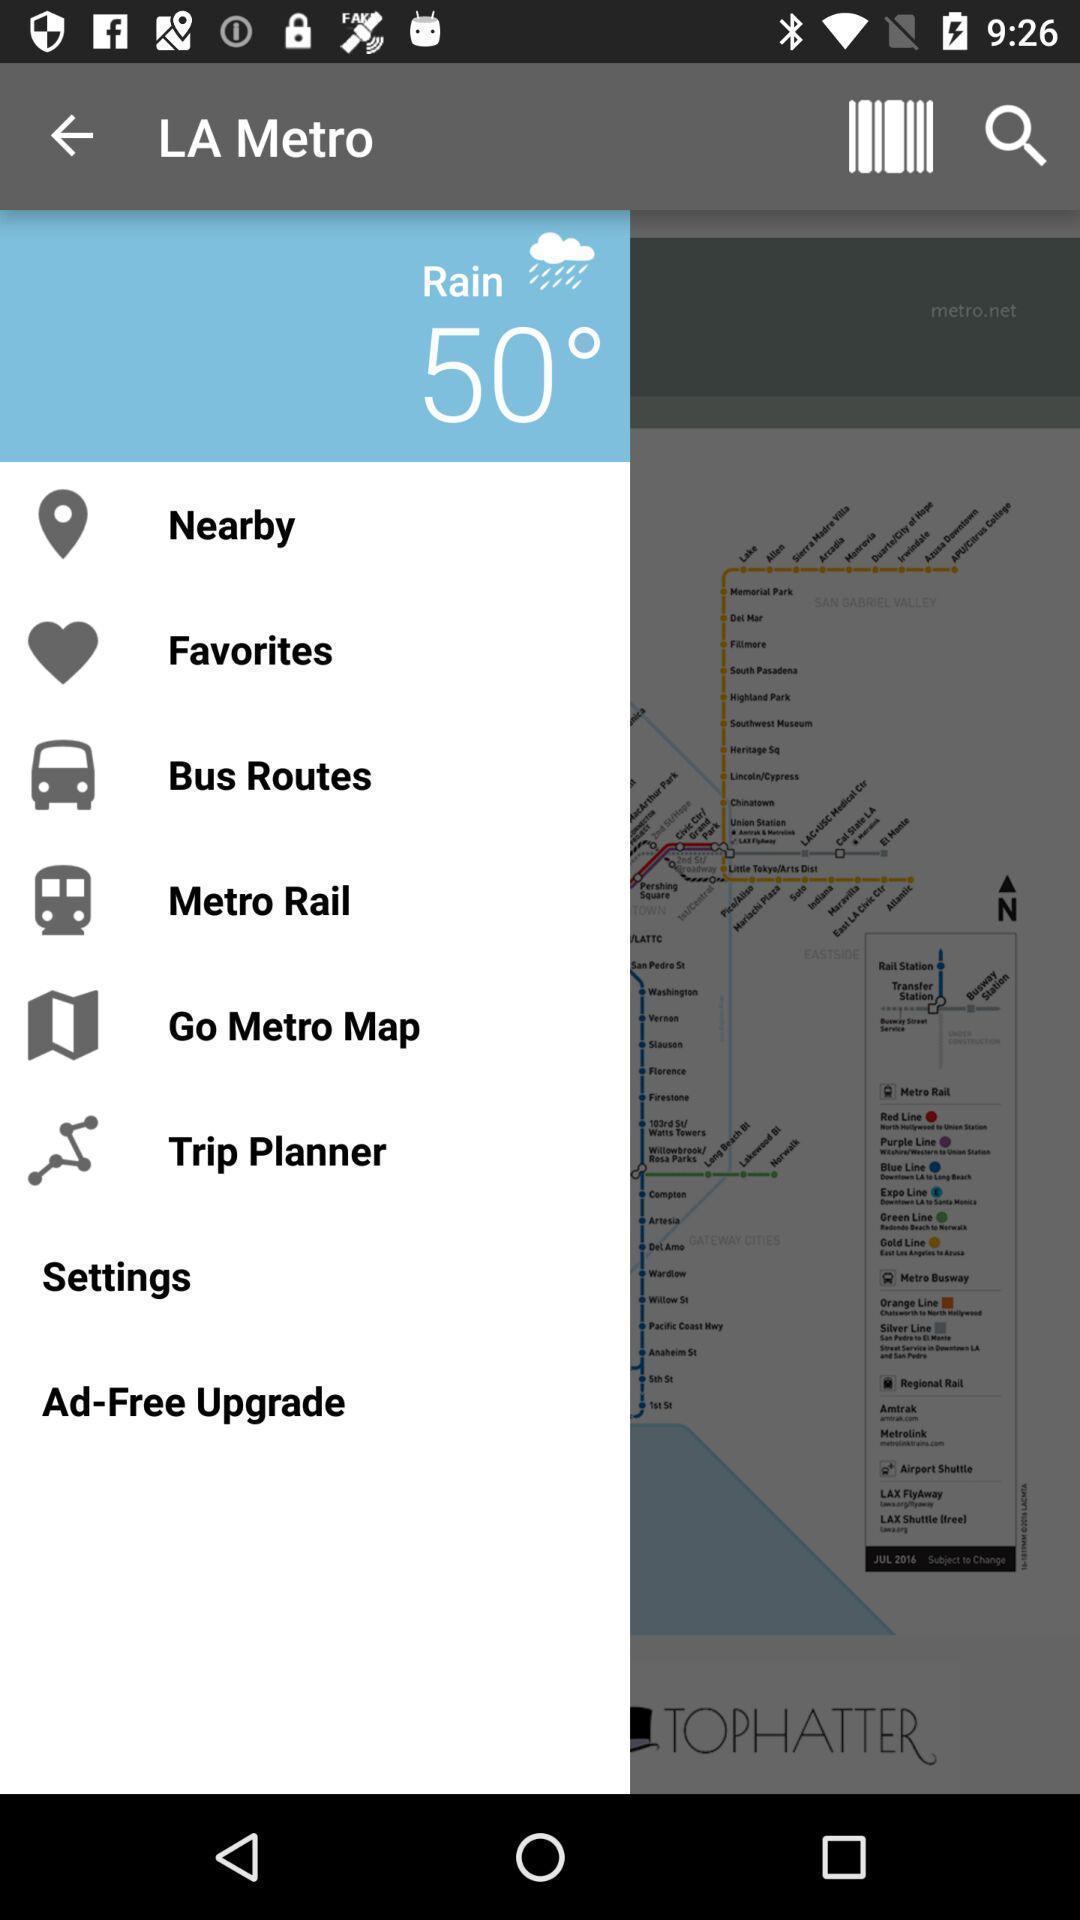Summarize the main components in this picture. Screen display list of multiple options in a travel app. 